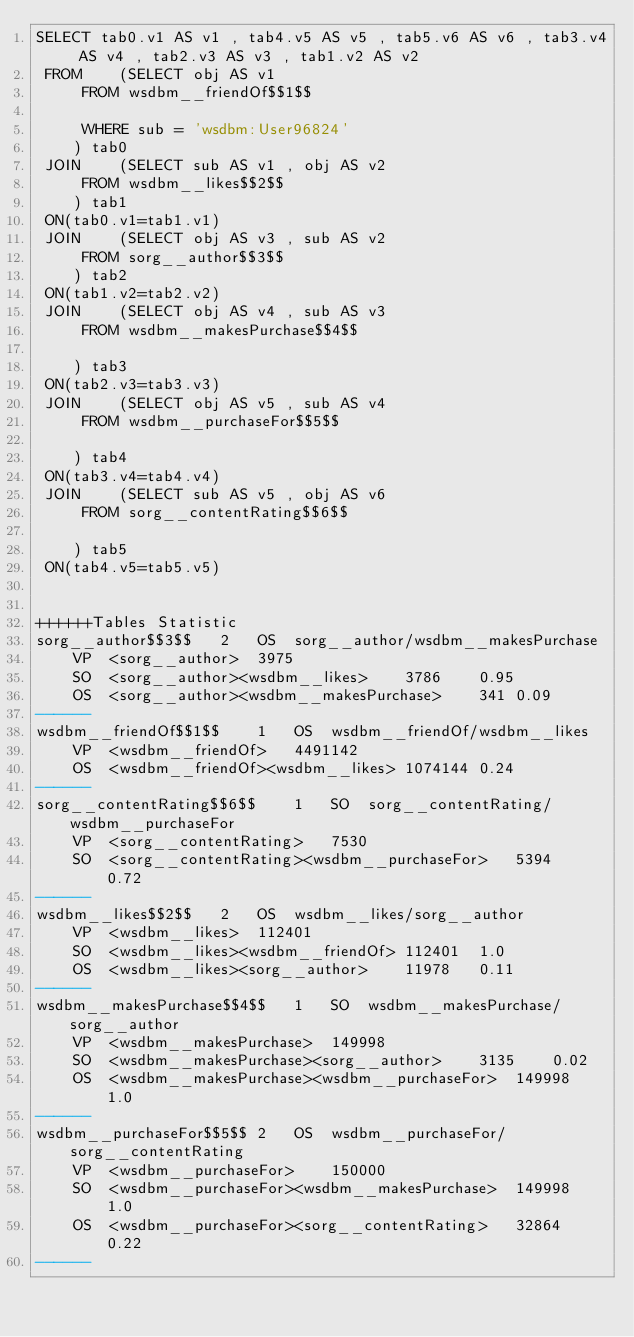<code> <loc_0><loc_0><loc_500><loc_500><_SQL_>SELECT tab0.v1 AS v1 , tab4.v5 AS v5 , tab5.v6 AS v6 , tab3.v4 AS v4 , tab2.v3 AS v3 , tab1.v2 AS v2 
 FROM    (SELECT obj AS v1 
	 FROM wsdbm__friendOf$$1$$
	 
	 WHERE sub = 'wsdbm:User96824'
	) tab0
 JOIN    (SELECT sub AS v1 , obj AS v2 
	 FROM wsdbm__likes$$2$$
	) tab1
 ON(tab0.v1=tab1.v1)
 JOIN    (SELECT obj AS v3 , sub AS v2 
	 FROM sorg__author$$3$$
	) tab2
 ON(tab1.v2=tab2.v2)
 JOIN    (SELECT obj AS v4 , sub AS v3 
	 FROM wsdbm__makesPurchase$$4$$
	
	) tab3
 ON(tab2.v3=tab3.v3)
 JOIN    (SELECT obj AS v5 , sub AS v4 
	 FROM wsdbm__purchaseFor$$5$$
	
	) tab4
 ON(tab3.v4=tab4.v4)
 JOIN    (SELECT sub AS v5 , obj AS v6 
	 FROM sorg__contentRating$$6$$
	
	) tab5
 ON(tab4.v5=tab5.v5)


++++++Tables Statistic
sorg__author$$3$$	2	OS	sorg__author/wsdbm__makesPurchase
	VP	<sorg__author>	3975
	SO	<sorg__author><wsdbm__likes>	3786	0.95
	OS	<sorg__author><wsdbm__makesPurchase>	341	0.09
------
wsdbm__friendOf$$1$$	1	OS	wsdbm__friendOf/wsdbm__likes
	VP	<wsdbm__friendOf>	4491142
	OS	<wsdbm__friendOf><wsdbm__likes>	1074144	0.24
------
sorg__contentRating$$6$$	1	SO	sorg__contentRating/wsdbm__purchaseFor
	VP	<sorg__contentRating>	7530
	SO	<sorg__contentRating><wsdbm__purchaseFor>	5394	0.72
------
wsdbm__likes$$2$$	2	OS	wsdbm__likes/sorg__author
	VP	<wsdbm__likes>	112401
	SO	<wsdbm__likes><wsdbm__friendOf>	112401	1.0
	OS	<wsdbm__likes><sorg__author>	11978	0.11
------
wsdbm__makesPurchase$$4$$	1	SO	wsdbm__makesPurchase/sorg__author
	VP	<wsdbm__makesPurchase>	149998
	SO	<wsdbm__makesPurchase><sorg__author>	3135	0.02
	OS	<wsdbm__makesPurchase><wsdbm__purchaseFor>	149998	1.0
------
wsdbm__purchaseFor$$5$$	2	OS	wsdbm__purchaseFor/sorg__contentRating
	VP	<wsdbm__purchaseFor>	150000
	SO	<wsdbm__purchaseFor><wsdbm__makesPurchase>	149998	1.0
	OS	<wsdbm__purchaseFor><sorg__contentRating>	32864	0.22
------
</code> 